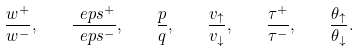Convert formula to latex. <formula><loc_0><loc_0><loc_500><loc_500>\frac { w ^ { + } } { w ^ { - } } , \quad \frac { \ e p s ^ { + } } { \ e p s ^ { - } } , \quad \frac { p } { q } , \quad \frac { v _ { \uparrow } } { v _ { \downarrow } } , \quad \frac { \tau ^ { + } } { \tau ^ { - } } , \quad \frac { \theta _ { \uparrow } } { \theta _ { \downarrow } } .</formula> 